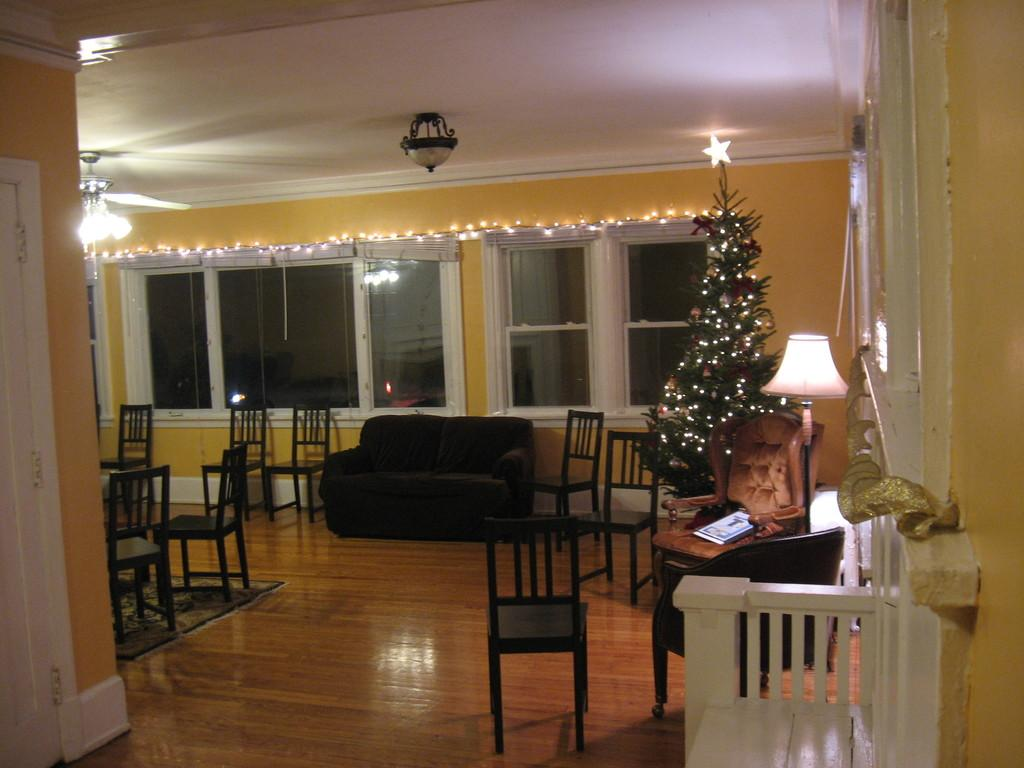What type of furniture is present in the image? There are chairs and a couch in the image. Is there any holiday-related decoration in the image? Yes, there is a Christmas tree to the right in the image. What type of lighting is present in the image? There is a lamp in the image. What can be seen in the background of the image? There is a window in the background of the image. What type of steel is used to construct the fifth chair in the image? There is no mention of a fifth chair in the image, and therefore no information about the type of steel used in its construction. 